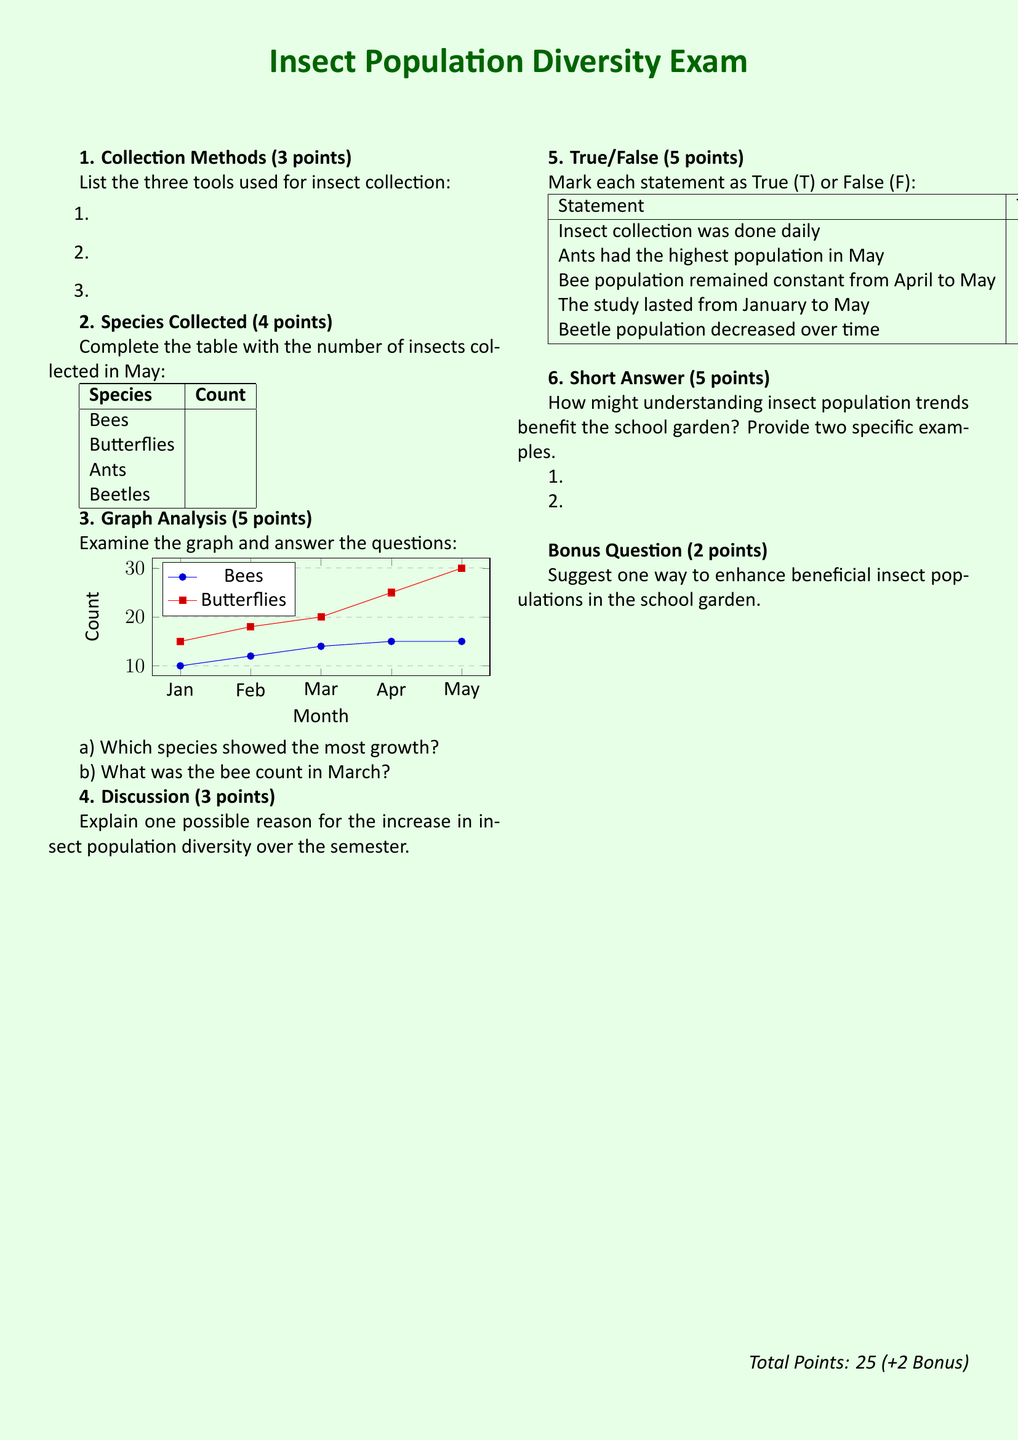What are the three tools used for insect collection? The document asks for tools without providing specific names; students are expected to list them from their knowledge.
Answer: N/A How many bees were collected in May? The answer is found in the species count table, which requires completion by the students.
Answer: N/A Which species had the highest count in May? This follows from the completion of the table for species collected in May, needing to be determined by students.
Answer: N/A What was the count of butterflies in April? The question requires analysis of the graph by students, deducing the data from visual representation.
Answer: N/A Which month showed the highest bee count? Students need to read and analyze both provided data and graphs to answer correctly.
Answer: N/A What is one possible reason for diversity increase? The discussion prompt encourages students to theorize based on collection changes throughout the semester.
Answer: N/A Did ant populations remain constant from January to May? This question relies on True/False marking based on analysis of population data throughout the months shown.
Answer: N/A What is the bonus question focused on? The bonus is about enhancing beneficial insect populations, specifically asking for student insight on this topic.
Answer: Enhancing beneficial insect populations How many points is the exam worth in total? The total points are provided at the end, which includes both regular and bonus points.
Answer: Twenty-five What is the main color of the background in the document? The formatting and design elements of the exam specify the background color used throughout the document.
Answer: Light green 